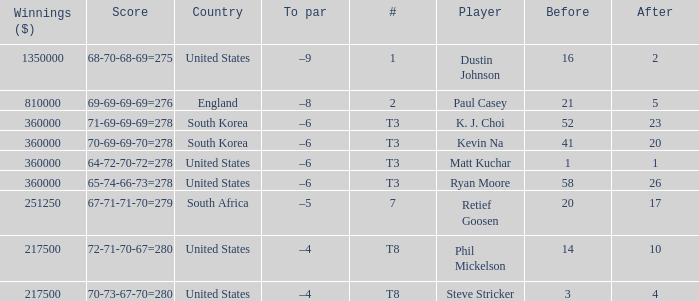What is the score when the player is Matt Kuchar? 64-72-70-72=278. 